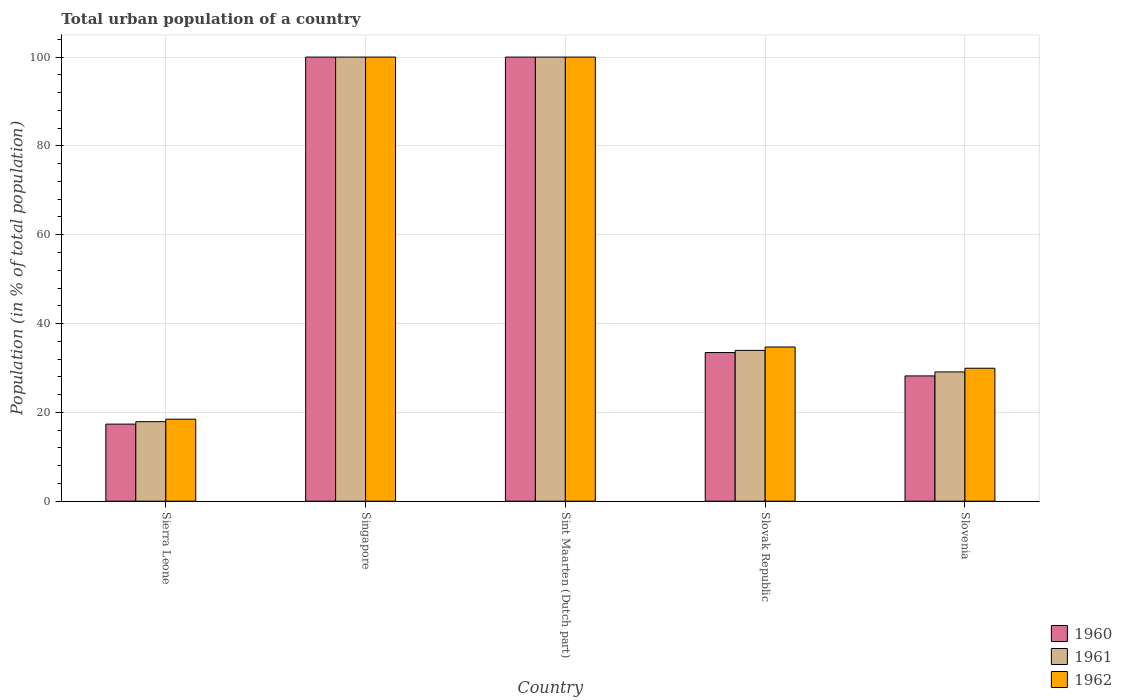How many different coloured bars are there?
Make the answer very short. 3. Are the number of bars per tick equal to the number of legend labels?
Your answer should be compact. Yes. Are the number of bars on each tick of the X-axis equal?
Give a very brief answer. Yes. What is the label of the 4th group of bars from the left?
Give a very brief answer. Slovak Republic. What is the urban population in 1962 in Singapore?
Offer a very short reply. 100. Across all countries, what is the maximum urban population in 1960?
Make the answer very short. 100. Across all countries, what is the minimum urban population in 1962?
Give a very brief answer. 18.47. In which country was the urban population in 1960 maximum?
Make the answer very short. Singapore. In which country was the urban population in 1961 minimum?
Offer a terse response. Sierra Leone. What is the total urban population in 1960 in the graph?
Provide a succinct answer. 279.02. What is the difference between the urban population in 1962 in Sierra Leone and that in Slovenia?
Keep it short and to the point. -11.47. What is the difference between the urban population in 1961 in Singapore and the urban population in 1962 in Slovenia?
Make the answer very short. 70.07. What is the average urban population in 1961 per country?
Offer a very short reply. 56.19. What is the difference between the urban population of/in 1961 and urban population of/in 1962 in Slovak Republic?
Provide a short and direct response. -0.76. In how many countries, is the urban population in 1960 greater than 24 %?
Make the answer very short. 4. What is the ratio of the urban population in 1960 in Sierra Leone to that in Singapore?
Your response must be concise. 0.17. Is the urban population in 1960 in Sierra Leone less than that in Slovak Republic?
Provide a short and direct response. Yes. What is the difference between the highest and the second highest urban population in 1961?
Keep it short and to the point. -66.05. What is the difference between the highest and the lowest urban population in 1960?
Keep it short and to the point. 82.65. Is the sum of the urban population in 1961 in Singapore and Slovak Republic greater than the maximum urban population in 1960 across all countries?
Make the answer very short. Yes. What does the 2nd bar from the left in Sint Maarten (Dutch part) represents?
Your answer should be very brief. 1961. What does the 1st bar from the right in Singapore represents?
Offer a terse response. 1962. Is it the case that in every country, the sum of the urban population in 1961 and urban population in 1962 is greater than the urban population in 1960?
Keep it short and to the point. Yes. What is the difference between two consecutive major ticks on the Y-axis?
Make the answer very short. 20. Are the values on the major ticks of Y-axis written in scientific E-notation?
Keep it short and to the point. No. Does the graph contain any zero values?
Your response must be concise. No. Does the graph contain grids?
Your answer should be compact. Yes. How are the legend labels stacked?
Make the answer very short. Vertical. What is the title of the graph?
Provide a short and direct response. Total urban population of a country. What is the label or title of the Y-axis?
Your answer should be very brief. Population (in % of total population). What is the Population (in % of total population) of 1960 in Sierra Leone?
Your answer should be compact. 17.35. What is the Population (in % of total population) in 1961 in Sierra Leone?
Offer a very short reply. 17.9. What is the Population (in % of total population) of 1962 in Sierra Leone?
Make the answer very short. 18.47. What is the Population (in % of total population) in 1960 in Singapore?
Offer a very short reply. 100. What is the Population (in % of total population) in 1961 in Singapore?
Your answer should be very brief. 100. What is the Population (in % of total population) of 1960 in Sint Maarten (Dutch part)?
Make the answer very short. 100. What is the Population (in % of total population) in 1960 in Slovak Republic?
Give a very brief answer. 33.46. What is the Population (in % of total population) of 1961 in Slovak Republic?
Make the answer very short. 33.95. What is the Population (in % of total population) of 1962 in Slovak Republic?
Your answer should be very brief. 34.71. What is the Population (in % of total population) in 1960 in Slovenia?
Your answer should be very brief. 28.2. What is the Population (in % of total population) of 1961 in Slovenia?
Offer a very short reply. 29.11. What is the Population (in % of total population) in 1962 in Slovenia?
Your answer should be compact. 29.93. Across all countries, what is the maximum Population (in % of total population) in 1960?
Give a very brief answer. 100. Across all countries, what is the maximum Population (in % of total population) of 1962?
Offer a very short reply. 100. Across all countries, what is the minimum Population (in % of total population) of 1960?
Offer a very short reply. 17.35. Across all countries, what is the minimum Population (in % of total population) of 1961?
Your response must be concise. 17.9. Across all countries, what is the minimum Population (in % of total population) in 1962?
Keep it short and to the point. 18.47. What is the total Population (in % of total population) in 1960 in the graph?
Offer a terse response. 279.02. What is the total Population (in % of total population) of 1961 in the graph?
Keep it short and to the point. 280.96. What is the total Population (in % of total population) of 1962 in the graph?
Your answer should be very brief. 283.12. What is the difference between the Population (in % of total population) in 1960 in Sierra Leone and that in Singapore?
Keep it short and to the point. -82.65. What is the difference between the Population (in % of total population) of 1961 in Sierra Leone and that in Singapore?
Make the answer very short. -82.1. What is the difference between the Population (in % of total population) of 1962 in Sierra Leone and that in Singapore?
Your answer should be very brief. -81.53. What is the difference between the Population (in % of total population) in 1960 in Sierra Leone and that in Sint Maarten (Dutch part)?
Your answer should be compact. -82.65. What is the difference between the Population (in % of total population) of 1961 in Sierra Leone and that in Sint Maarten (Dutch part)?
Your answer should be very brief. -82.1. What is the difference between the Population (in % of total population) of 1962 in Sierra Leone and that in Sint Maarten (Dutch part)?
Your answer should be very brief. -81.53. What is the difference between the Population (in % of total population) of 1960 in Sierra Leone and that in Slovak Republic?
Provide a succinct answer. -16.11. What is the difference between the Population (in % of total population) in 1961 in Sierra Leone and that in Slovak Republic?
Give a very brief answer. -16.05. What is the difference between the Population (in % of total population) in 1962 in Sierra Leone and that in Slovak Republic?
Your answer should be very brief. -16.25. What is the difference between the Population (in % of total population) of 1960 in Sierra Leone and that in Slovenia?
Give a very brief answer. -10.85. What is the difference between the Population (in % of total population) in 1961 in Sierra Leone and that in Slovenia?
Your answer should be compact. -11.2. What is the difference between the Population (in % of total population) in 1962 in Sierra Leone and that in Slovenia?
Offer a terse response. -11.47. What is the difference between the Population (in % of total population) of 1960 in Singapore and that in Sint Maarten (Dutch part)?
Provide a short and direct response. 0. What is the difference between the Population (in % of total population) of 1960 in Singapore and that in Slovak Republic?
Offer a terse response. 66.54. What is the difference between the Population (in % of total population) of 1961 in Singapore and that in Slovak Republic?
Keep it short and to the point. 66.05. What is the difference between the Population (in % of total population) in 1962 in Singapore and that in Slovak Republic?
Ensure brevity in your answer.  65.29. What is the difference between the Population (in % of total population) of 1960 in Singapore and that in Slovenia?
Offer a very short reply. 71.8. What is the difference between the Population (in % of total population) of 1961 in Singapore and that in Slovenia?
Offer a terse response. 70.89. What is the difference between the Population (in % of total population) in 1962 in Singapore and that in Slovenia?
Provide a short and direct response. 70.07. What is the difference between the Population (in % of total population) in 1960 in Sint Maarten (Dutch part) and that in Slovak Republic?
Offer a very short reply. 66.54. What is the difference between the Population (in % of total population) of 1961 in Sint Maarten (Dutch part) and that in Slovak Republic?
Make the answer very short. 66.05. What is the difference between the Population (in % of total population) in 1962 in Sint Maarten (Dutch part) and that in Slovak Republic?
Your answer should be very brief. 65.29. What is the difference between the Population (in % of total population) in 1960 in Sint Maarten (Dutch part) and that in Slovenia?
Give a very brief answer. 71.8. What is the difference between the Population (in % of total population) of 1961 in Sint Maarten (Dutch part) and that in Slovenia?
Keep it short and to the point. 70.89. What is the difference between the Population (in % of total population) of 1962 in Sint Maarten (Dutch part) and that in Slovenia?
Your answer should be compact. 70.07. What is the difference between the Population (in % of total population) of 1960 in Slovak Republic and that in Slovenia?
Make the answer very short. 5.26. What is the difference between the Population (in % of total population) in 1961 in Slovak Republic and that in Slovenia?
Give a very brief answer. 4.85. What is the difference between the Population (in % of total population) in 1962 in Slovak Republic and that in Slovenia?
Your response must be concise. 4.78. What is the difference between the Population (in % of total population) of 1960 in Sierra Leone and the Population (in % of total population) of 1961 in Singapore?
Give a very brief answer. -82.65. What is the difference between the Population (in % of total population) in 1960 in Sierra Leone and the Population (in % of total population) in 1962 in Singapore?
Your answer should be very brief. -82.65. What is the difference between the Population (in % of total population) of 1961 in Sierra Leone and the Population (in % of total population) of 1962 in Singapore?
Offer a terse response. -82.1. What is the difference between the Population (in % of total population) in 1960 in Sierra Leone and the Population (in % of total population) in 1961 in Sint Maarten (Dutch part)?
Make the answer very short. -82.65. What is the difference between the Population (in % of total population) in 1960 in Sierra Leone and the Population (in % of total population) in 1962 in Sint Maarten (Dutch part)?
Give a very brief answer. -82.65. What is the difference between the Population (in % of total population) of 1961 in Sierra Leone and the Population (in % of total population) of 1962 in Sint Maarten (Dutch part)?
Your response must be concise. -82.1. What is the difference between the Population (in % of total population) of 1960 in Sierra Leone and the Population (in % of total population) of 1961 in Slovak Republic?
Your answer should be compact. -16.6. What is the difference between the Population (in % of total population) in 1960 in Sierra Leone and the Population (in % of total population) in 1962 in Slovak Republic?
Keep it short and to the point. -17.36. What is the difference between the Population (in % of total population) in 1961 in Sierra Leone and the Population (in % of total population) in 1962 in Slovak Republic?
Give a very brief answer. -16.81. What is the difference between the Population (in % of total population) in 1960 in Sierra Leone and the Population (in % of total population) in 1961 in Slovenia?
Give a very brief answer. -11.76. What is the difference between the Population (in % of total population) in 1960 in Sierra Leone and the Population (in % of total population) in 1962 in Slovenia?
Keep it short and to the point. -12.58. What is the difference between the Population (in % of total population) of 1961 in Sierra Leone and the Population (in % of total population) of 1962 in Slovenia?
Give a very brief answer. -12.03. What is the difference between the Population (in % of total population) in 1960 in Singapore and the Population (in % of total population) in 1961 in Slovak Republic?
Ensure brevity in your answer.  66.05. What is the difference between the Population (in % of total population) in 1960 in Singapore and the Population (in % of total population) in 1962 in Slovak Republic?
Offer a very short reply. 65.29. What is the difference between the Population (in % of total population) in 1961 in Singapore and the Population (in % of total population) in 1962 in Slovak Republic?
Your answer should be compact. 65.29. What is the difference between the Population (in % of total population) of 1960 in Singapore and the Population (in % of total population) of 1961 in Slovenia?
Provide a short and direct response. 70.89. What is the difference between the Population (in % of total population) in 1960 in Singapore and the Population (in % of total population) in 1962 in Slovenia?
Your response must be concise. 70.07. What is the difference between the Population (in % of total population) in 1961 in Singapore and the Population (in % of total population) in 1962 in Slovenia?
Offer a terse response. 70.07. What is the difference between the Population (in % of total population) of 1960 in Sint Maarten (Dutch part) and the Population (in % of total population) of 1961 in Slovak Republic?
Your answer should be very brief. 66.05. What is the difference between the Population (in % of total population) of 1960 in Sint Maarten (Dutch part) and the Population (in % of total population) of 1962 in Slovak Republic?
Your answer should be very brief. 65.29. What is the difference between the Population (in % of total population) in 1961 in Sint Maarten (Dutch part) and the Population (in % of total population) in 1962 in Slovak Republic?
Your answer should be very brief. 65.29. What is the difference between the Population (in % of total population) in 1960 in Sint Maarten (Dutch part) and the Population (in % of total population) in 1961 in Slovenia?
Offer a terse response. 70.89. What is the difference between the Population (in % of total population) of 1960 in Sint Maarten (Dutch part) and the Population (in % of total population) of 1962 in Slovenia?
Offer a very short reply. 70.07. What is the difference between the Population (in % of total population) in 1961 in Sint Maarten (Dutch part) and the Population (in % of total population) in 1962 in Slovenia?
Keep it short and to the point. 70.07. What is the difference between the Population (in % of total population) of 1960 in Slovak Republic and the Population (in % of total population) of 1961 in Slovenia?
Give a very brief answer. 4.36. What is the difference between the Population (in % of total population) of 1960 in Slovak Republic and the Population (in % of total population) of 1962 in Slovenia?
Offer a terse response. 3.53. What is the difference between the Population (in % of total population) of 1961 in Slovak Republic and the Population (in % of total population) of 1962 in Slovenia?
Offer a terse response. 4.02. What is the average Population (in % of total population) of 1960 per country?
Provide a succinct answer. 55.8. What is the average Population (in % of total population) of 1961 per country?
Your answer should be very brief. 56.19. What is the average Population (in % of total population) in 1962 per country?
Your response must be concise. 56.62. What is the difference between the Population (in % of total population) in 1960 and Population (in % of total population) in 1961 in Sierra Leone?
Give a very brief answer. -0.55. What is the difference between the Population (in % of total population) of 1960 and Population (in % of total population) of 1962 in Sierra Leone?
Give a very brief answer. -1.11. What is the difference between the Population (in % of total population) in 1961 and Population (in % of total population) in 1962 in Sierra Leone?
Provide a succinct answer. -0.56. What is the difference between the Population (in % of total population) in 1960 and Population (in % of total population) in 1961 in Singapore?
Your response must be concise. 0. What is the difference between the Population (in % of total population) in 1960 and Population (in % of total population) in 1962 in Singapore?
Your response must be concise. 0. What is the difference between the Population (in % of total population) of 1961 and Population (in % of total population) of 1962 in Singapore?
Make the answer very short. 0. What is the difference between the Population (in % of total population) in 1960 and Population (in % of total population) in 1962 in Sint Maarten (Dutch part)?
Your answer should be compact. 0. What is the difference between the Population (in % of total population) of 1960 and Population (in % of total population) of 1961 in Slovak Republic?
Give a very brief answer. -0.49. What is the difference between the Population (in % of total population) in 1960 and Population (in % of total population) in 1962 in Slovak Republic?
Your answer should be very brief. -1.25. What is the difference between the Population (in % of total population) of 1961 and Population (in % of total population) of 1962 in Slovak Republic?
Your answer should be very brief. -0.76. What is the difference between the Population (in % of total population) of 1960 and Population (in % of total population) of 1961 in Slovenia?
Offer a terse response. -0.9. What is the difference between the Population (in % of total population) in 1960 and Population (in % of total population) in 1962 in Slovenia?
Give a very brief answer. -1.73. What is the difference between the Population (in % of total population) in 1961 and Population (in % of total population) in 1962 in Slovenia?
Your answer should be very brief. -0.83. What is the ratio of the Population (in % of total population) of 1960 in Sierra Leone to that in Singapore?
Offer a very short reply. 0.17. What is the ratio of the Population (in % of total population) in 1961 in Sierra Leone to that in Singapore?
Provide a succinct answer. 0.18. What is the ratio of the Population (in % of total population) of 1962 in Sierra Leone to that in Singapore?
Ensure brevity in your answer.  0.18. What is the ratio of the Population (in % of total population) of 1960 in Sierra Leone to that in Sint Maarten (Dutch part)?
Provide a succinct answer. 0.17. What is the ratio of the Population (in % of total population) of 1961 in Sierra Leone to that in Sint Maarten (Dutch part)?
Your answer should be very brief. 0.18. What is the ratio of the Population (in % of total population) of 1962 in Sierra Leone to that in Sint Maarten (Dutch part)?
Your answer should be very brief. 0.18. What is the ratio of the Population (in % of total population) in 1960 in Sierra Leone to that in Slovak Republic?
Provide a succinct answer. 0.52. What is the ratio of the Population (in % of total population) in 1961 in Sierra Leone to that in Slovak Republic?
Give a very brief answer. 0.53. What is the ratio of the Population (in % of total population) in 1962 in Sierra Leone to that in Slovak Republic?
Give a very brief answer. 0.53. What is the ratio of the Population (in % of total population) in 1960 in Sierra Leone to that in Slovenia?
Your answer should be compact. 0.62. What is the ratio of the Population (in % of total population) of 1961 in Sierra Leone to that in Slovenia?
Offer a terse response. 0.62. What is the ratio of the Population (in % of total population) of 1962 in Sierra Leone to that in Slovenia?
Provide a short and direct response. 0.62. What is the ratio of the Population (in % of total population) of 1962 in Singapore to that in Sint Maarten (Dutch part)?
Provide a short and direct response. 1. What is the ratio of the Population (in % of total population) of 1960 in Singapore to that in Slovak Republic?
Your answer should be very brief. 2.99. What is the ratio of the Population (in % of total population) in 1961 in Singapore to that in Slovak Republic?
Provide a short and direct response. 2.95. What is the ratio of the Population (in % of total population) of 1962 in Singapore to that in Slovak Republic?
Give a very brief answer. 2.88. What is the ratio of the Population (in % of total population) of 1960 in Singapore to that in Slovenia?
Your answer should be compact. 3.55. What is the ratio of the Population (in % of total population) of 1961 in Singapore to that in Slovenia?
Ensure brevity in your answer.  3.44. What is the ratio of the Population (in % of total population) of 1962 in Singapore to that in Slovenia?
Your response must be concise. 3.34. What is the ratio of the Population (in % of total population) of 1960 in Sint Maarten (Dutch part) to that in Slovak Republic?
Provide a succinct answer. 2.99. What is the ratio of the Population (in % of total population) of 1961 in Sint Maarten (Dutch part) to that in Slovak Republic?
Provide a short and direct response. 2.95. What is the ratio of the Population (in % of total population) in 1962 in Sint Maarten (Dutch part) to that in Slovak Republic?
Provide a succinct answer. 2.88. What is the ratio of the Population (in % of total population) in 1960 in Sint Maarten (Dutch part) to that in Slovenia?
Ensure brevity in your answer.  3.55. What is the ratio of the Population (in % of total population) of 1961 in Sint Maarten (Dutch part) to that in Slovenia?
Ensure brevity in your answer.  3.44. What is the ratio of the Population (in % of total population) in 1962 in Sint Maarten (Dutch part) to that in Slovenia?
Make the answer very short. 3.34. What is the ratio of the Population (in % of total population) of 1960 in Slovak Republic to that in Slovenia?
Your answer should be very brief. 1.19. What is the ratio of the Population (in % of total population) in 1961 in Slovak Republic to that in Slovenia?
Your answer should be very brief. 1.17. What is the ratio of the Population (in % of total population) in 1962 in Slovak Republic to that in Slovenia?
Provide a succinct answer. 1.16. What is the difference between the highest and the lowest Population (in % of total population) of 1960?
Provide a short and direct response. 82.65. What is the difference between the highest and the lowest Population (in % of total population) of 1961?
Your answer should be compact. 82.1. What is the difference between the highest and the lowest Population (in % of total population) of 1962?
Provide a short and direct response. 81.53. 